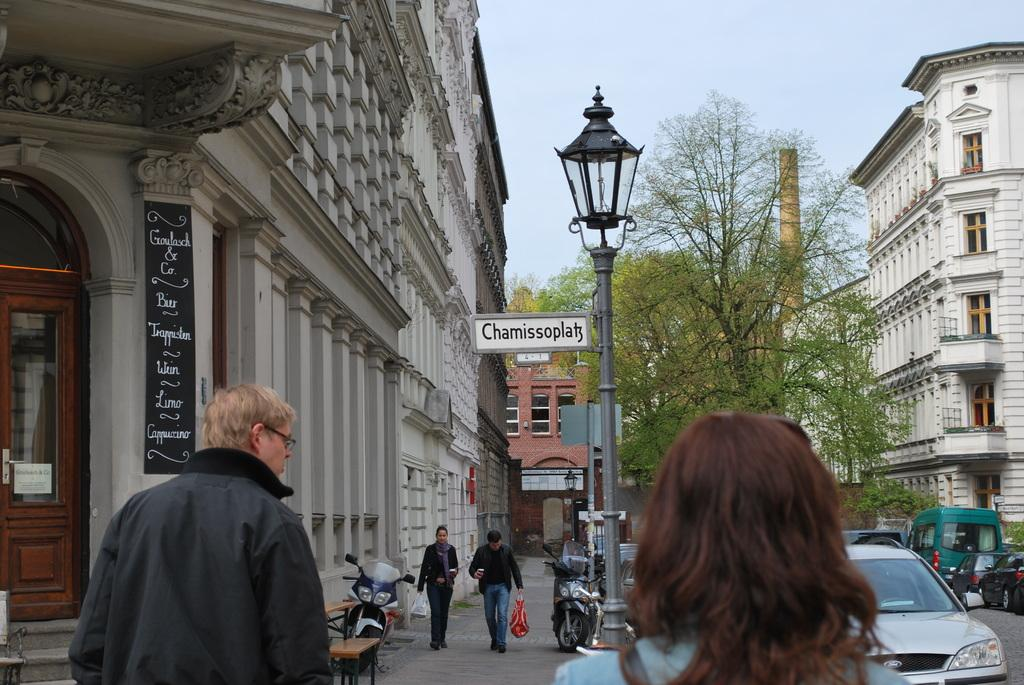What types of transportation can be seen on the road in the image? Vehicles are on the road in the image. Can you describe the people in the image? There are people in the image. What mode of transportation is also present in the image? Bikes are present in the image. What type of structures are visible in the image? Buildings with windows are visible. What is attached to the lamp pole in the image? A board is on a lamp pole. What type of vegetation is present in the image? Trees are present in the image. Where is the crown placed in the image? There is no crown present in the image. What type of calculations can be performed using the calculator in the image? There is no calculator present in the image. 